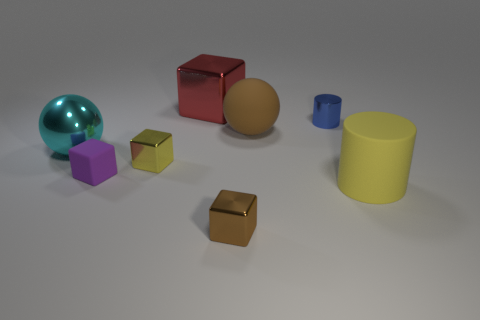Subtract all purple matte blocks. How many blocks are left? 3 Add 1 big purple rubber balls. How many objects exist? 9 Subtract all yellow blocks. How many blocks are left? 3 Subtract 1 blocks. How many blocks are left? 3 Subtract 1 blue cylinders. How many objects are left? 7 Subtract all spheres. How many objects are left? 6 Subtract all cyan cubes. Subtract all yellow spheres. How many cubes are left? 4 Subtract all tiny yellow shiny balls. Subtract all small blue cylinders. How many objects are left? 7 Add 2 big rubber cylinders. How many big rubber cylinders are left? 3 Add 7 yellow objects. How many yellow objects exist? 9 